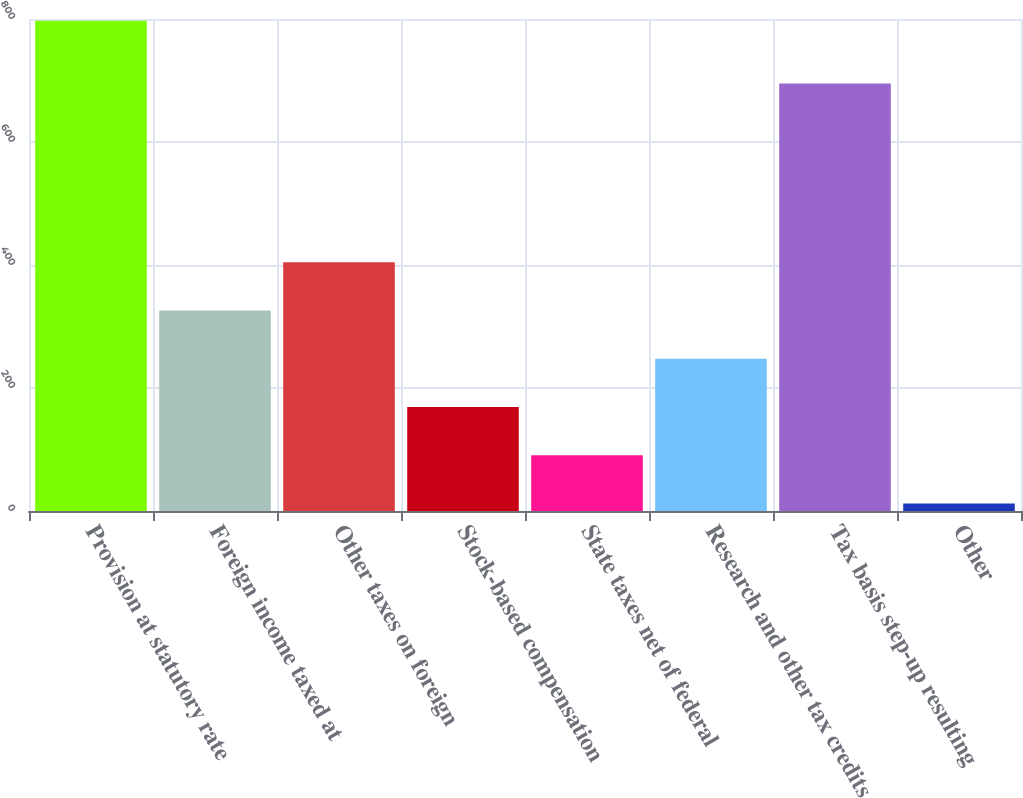<chart> <loc_0><loc_0><loc_500><loc_500><bar_chart><fcel>Provision at statutory rate<fcel>Foreign income taxed at<fcel>Other taxes on foreign<fcel>Stock-based compensation<fcel>State taxes net of federal<fcel>Research and other tax credits<fcel>Tax basis step-up resulting<fcel>Other<nl><fcel>797<fcel>326<fcel>404.5<fcel>169<fcel>90.5<fcel>247.5<fcel>695<fcel>12<nl></chart> 